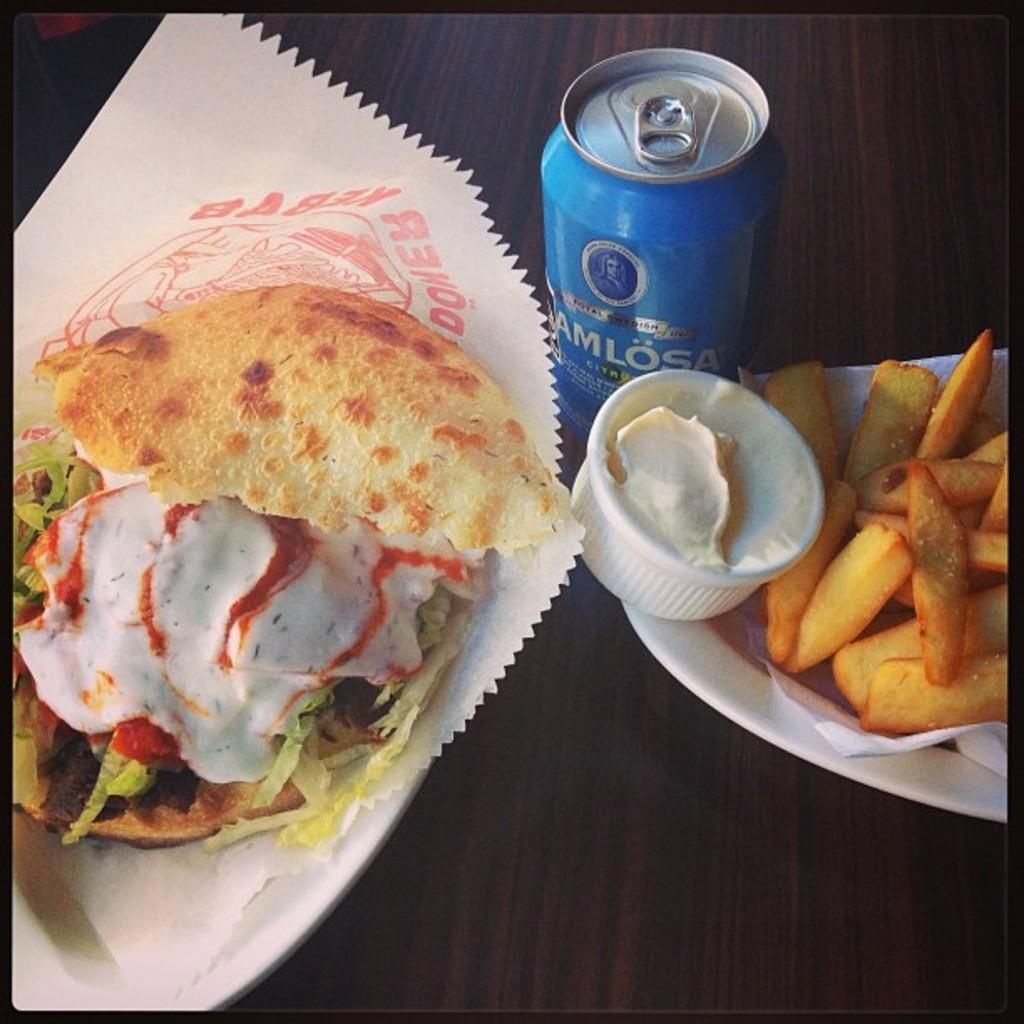What type of food is on the plate in the image? There is a burger on a plate in the image. What other food item is on the plate with the burger? There are fries on the plate in the image. What beverage container is on the table in the image? There is a beverage can on the table in the image. What color of paint is used on the bike in the image? There is no bike present in the image, so the color of paint cannot be determined. 